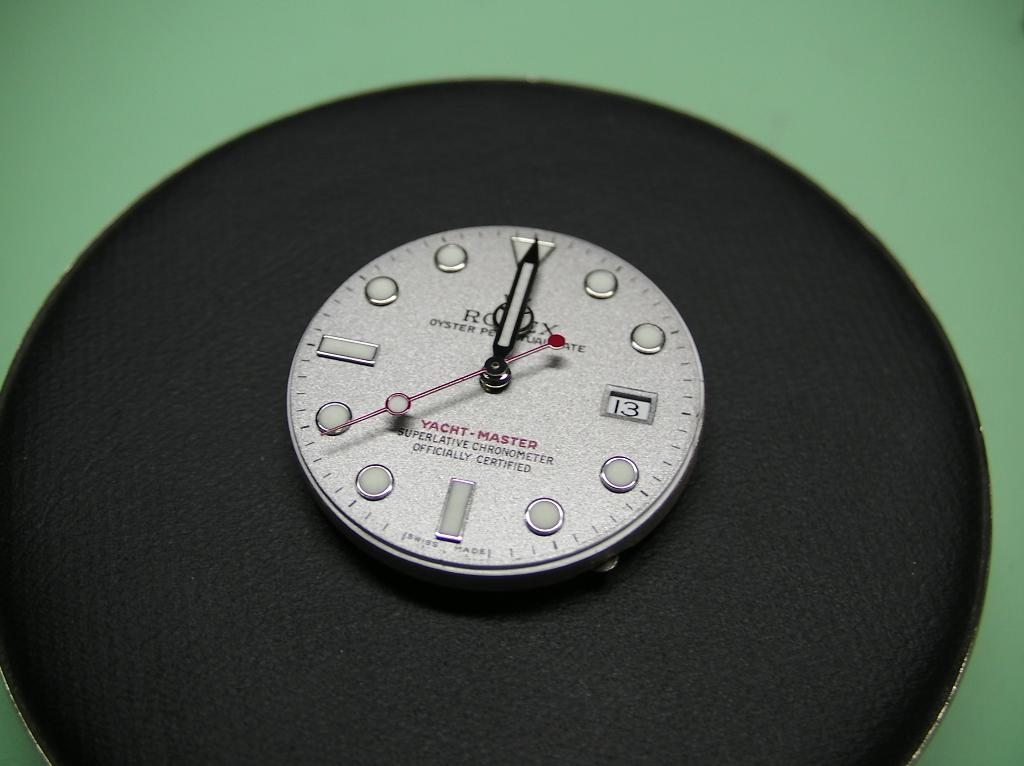<image>
Describe the image concisely. a clock that has the number 13 on it 